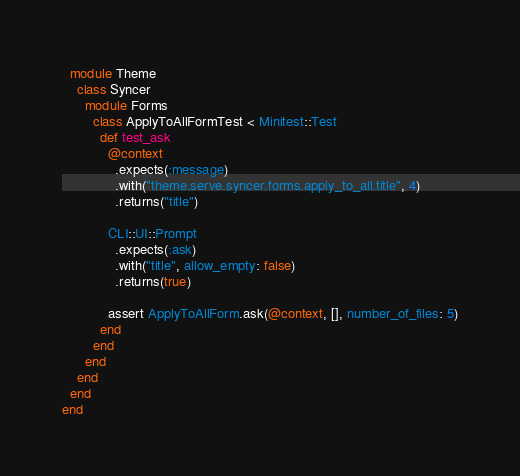<code> <loc_0><loc_0><loc_500><loc_500><_Ruby_>  module Theme
    class Syncer
      module Forms
        class ApplyToAllFormTest < Minitest::Test
          def test_ask
            @context
              .expects(:message)
              .with("theme.serve.syncer.forms.apply_to_all.title", 4)
              .returns("title")

            CLI::UI::Prompt
              .expects(:ask)
              .with("title", allow_empty: false)
              .returns(true)

            assert ApplyToAllForm.ask(@context, [], number_of_files: 5)
          end
        end
      end
    end
  end
end
</code> 